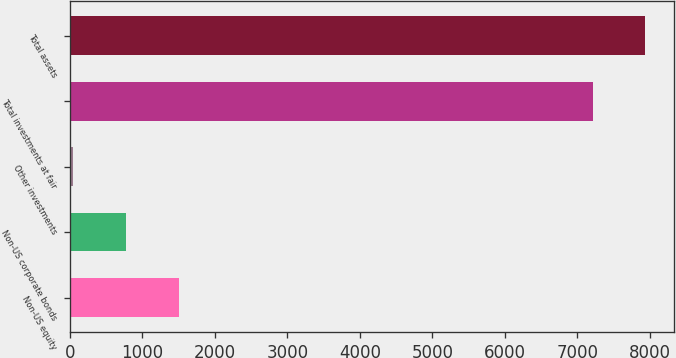Convert chart to OTSL. <chart><loc_0><loc_0><loc_500><loc_500><bar_chart><fcel>Non-US equity<fcel>Non-US corporate bonds<fcel>Other investments<fcel>Total investments at fair<fcel>Total assets<nl><fcel>1500.2<fcel>772.6<fcel>45<fcel>7210<fcel>7937.6<nl></chart> 